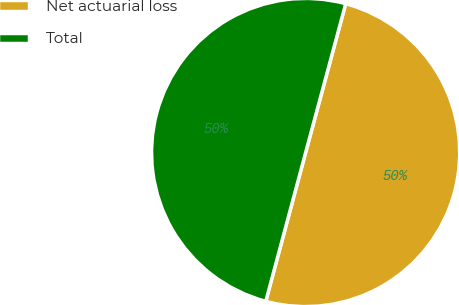Convert chart to OTSL. <chart><loc_0><loc_0><loc_500><loc_500><pie_chart><fcel>Net actuarial loss<fcel>Total<nl><fcel>49.98%<fcel>50.02%<nl></chart> 